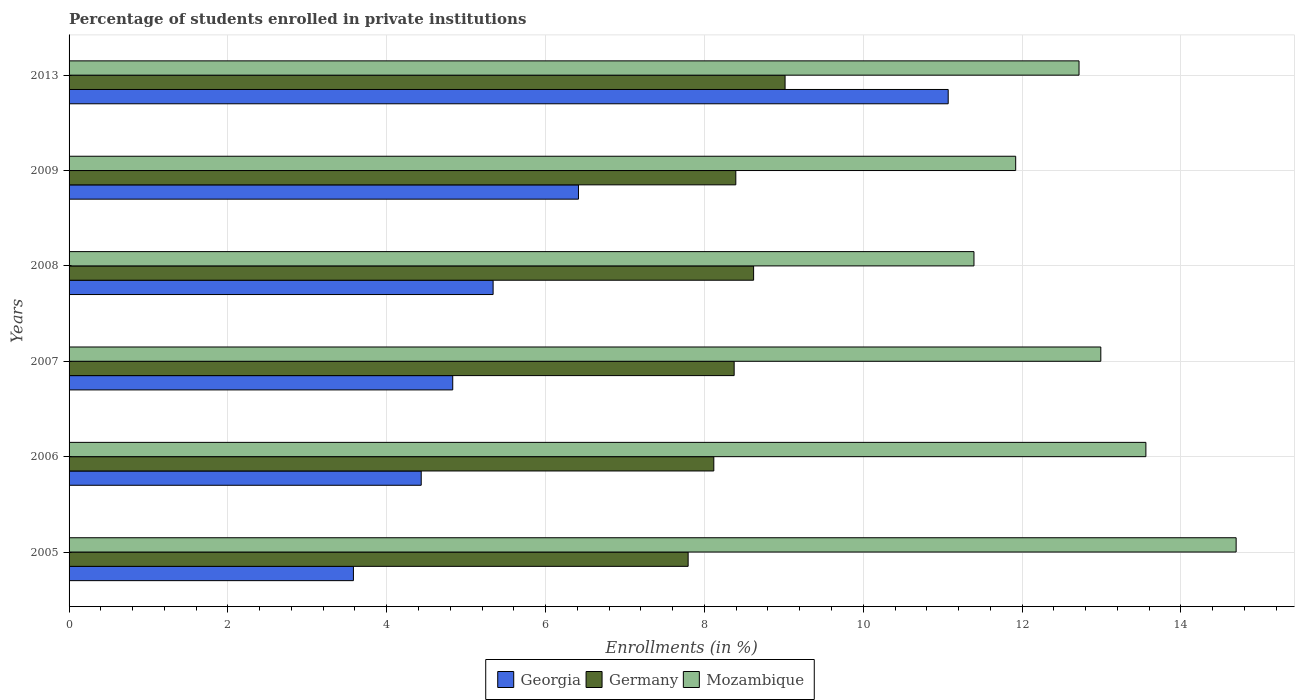How many different coloured bars are there?
Provide a succinct answer. 3. How many groups of bars are there?
Your response must be concise. 6. Are the number of bars per tick equal to the number of legend labels?
Give a very brief answer. Yes. What is the label of the 3rd group of bars from the top?
Provide a succinct answer. 2008. In how many cases, is the number of bars for a given year not equal to the number of legend labels?
Keep it short and to the point. 0. What is the percentage of trained teachers in Georgia in 2013?
Keep it short and to the point. 11.07. Across all years, what is the maximum percentage of trained teachers in Mozambique?
Provide a short and direct response. 14.7. Across all years, what is the minimum percentage of trained teachers in Germany?
Your response must be concise. 7.8. What is the total percentage of trained teachers in Germany in the graph?
Your answer should be compact. 50.32. What is the difference between the percentage of trained teachers in Germany in 2007 and that in 2008?
Offer a very short reply. -0.24. What is the difference between the percentage of trained teachers in Germany in 2008 and the percentage of trained teachers in Georgia in 2007?
Your response must be concise. 3.79. What is the average percentage of trained teachers in Georgia per year?
Your answer should be very brief. 5.94. In the year 2006, what is the difference between the percentage of trained teachers in Georgia and percentage of trained teachers in Mozambique?
Offer a terse response. -9.12. In how many years, is the percentage of trained teachers in Mozambique greater than 10.8 %?
Your answer should be very brief. 6. What is the ratio of the percentage of trained teachers in Germany in 2006 to that in 2009?
Provide a succinct answer. 0.97. Is the percentage of trained teachers in Georgia in 2006 less than that in 2013?
Your answer should be very brief. Yes. What is the difference between the highest and the second highest percentage of trained teachers in Georgia?
Keep it short and to the point. 4.66. What is the difference between the highest and the lowest percentage of trained teachers in Georgia?
Keep it short and to the point. 7.49. Is the sum of the percentage of trained teachers in Germany in 2005 and 2006 greater than the maximum percentage of trained teachers in Georgia across all years?
Your response must be concise. Yes. What does the 2nd bar from the top in 2006 represents?
Your response must be concise. Germany. What does the 1st bar from the bottom in 2007 represents?
Provide a succinct answer. Georgia. How many bars are there?
Your answer should be very brief. 18. What is the difference between two consecutive major ticks on the X-axis?
Your response must be concise. 2. What is the title of the graph?
Keep it short and to the point. Percentage of students enrolled in private institutions. Does "Syrian Arab Republic" appear as one of the legend labels in the graph?
Provide a succinct answer. No. What is the label or title of the X-axis?
Ensure brevity in your answer.  Enrollments (in %). What is the Enrollments (in %) in Georgia in 2005?
Give a very brief answer. 3.58. What is the Enrollments (in %) in Germany in 2005?
Offer a terse response. 7.8. What is the Enrollments (in %) of Mozambique in 2005?
Make the answer very short. 14.7. What is the Enrollments (in %) in Georgia in 2006?
Your response must be concise. 4.43. What is the Enrollments (in %) of Germany in 2006?
Offer a very short reply. 8.12. What is the Enrollments (in %) of Mozambique in 2006?
Offer a terse response. 13.56. What is the Enrollments (in %) of Georgia in 2007?
Ensure brevity in your answer.  4.83. What is the Enrollments (in %) of Germany in 2007?
Ensure brevity in your answer.  8.37. What is the Enrollments (in %) in Mozambique in 2007?
Make the answer very short. 12.99. What is the Enrollments (in %) in Georgia in 2008?
Offer a terse response. 5.34. What is the Enrollments (in %) in Germany in 2008?
Give a very brief answer. 8.62. What is the Enrollments (in %) of Mozambique in 2008?
Provide a short and direct response. 11.39. What is the Enrollments (in %) of Georgia in 2009?
Make the answer very short. 6.41. What is the Enrollments (in %) of Germany in 2009?
Offer a very short reply. 8.4. What is the Enrollments (in %) in Mozambique in 2009?
Ensure brevity in your answer.  11.92. What is the Enrollments (in %) in Georgia in 2013?
Your response must be concise. 11.07. What is the Enrollments (in %) of Germany in 2013?
Provide a short and direct response. 9.02. What is the Enrollments (in %) of Mozambique in 2013?
Offer a very short reply. 12.72. Across all years, what is the maximum Enrollments (in %) of Georgia?
Your response must be concise. 11.07. Across all years, what is the maximum Enrollments (in %) of Germany?
Your answer should be compact. 9.02. Across all years, what is the maximum Enrollments (in %) in Mozambique?
Your answer should be very brief. 14.7. Across all years, what is the minimum Enrollments (in %) in Georgia?
Your answer should be compact. 3.58. Across all years, what is the minimum Enrollments (in %) of Germany?
Ensure brevity in your answer.  7.8. Across all years, what is the minimum Enrollments (in %) in Mozambique?
Your answer should be very brief. 11.39. What is the total Enrollments (in %) in Georgia in the graph?
Keep it short and to the point. 35.67. What is the total Enrollments (in %) in Germany in the graph?
Ensure brevity in your answer.  50.32. What is the total Enrollments (in %) of Mozambique in the graph?
Ensure brevity in your answer.  77.28. What is the difference between the Enrollments (in %) in Georgia in 2005 and that in 2006?
Provide a short and direct response. -0.85. What is the difference between the Enrollments (in %) in Germany in 2005 and that in 2006?
Your response must be concise. -0.32. What is the difference between the Enrollments (in %) of Mozambique in 2005 and that in 2006?
Provide a succinct answer. 1.14. What is the difference between the Enrollments (in %) of Georgia in 2005 and that in 2007?
Give a very brief answer. -1.25. What is the difference between the Enrollments (in %) in Germany in 2005 and that in 2007?
Ensure brevity in your answer.  -0.58. What is the difference between the Enrollments (in %) in Mozambique in 2005 and that in 2007?
Make the answer very short. 1.7. What is the difference between the Enrollments (in %) of Georgia in 2005 and that in 2008?
Keep it short and to the point. -1.76. What is the difference between the Enrollments (in %) in Germany in 2005 and that in 2008?
Your answer should be compact. -0.82. What is the difference between the Enrollments (in %) in Mozambique in 2005 and that in 2008?
Provide a succinct answer. 3.3. What is the difference between the Enrollments (in %) of Georgia in 2005 and that in 2009?
Give a very brief answer. -2.83. What is the difference between the Enrollments (in %) in Germany in 2005 and that in 2009?
Offer a terse response. -0.6. What is the difference between the Enrollments (in %) of Mozambique in 2005 and that in 2009?
Ensure brevity in your answer.  2.78. What is the difference between the Enrollments (in %) in Georgia in 2005 and that in 2013?
Ensure brevity in your answer.  -7.49. What is the difference between the Enrollments (in %) in Germany in 2005 and that in 2013?
Your answer should be compact. -1.22. What is the difference between the Enrollments (in %) in Mozambique in 2005 and that in 2013?
Keep it short and to the point. 1.98. What is the difference between the Enrollments (in %) in Georgia in 2006 and that in 2007?
Ensure brevity in your answer.  -0.4. What is the difference between the Enrollments (in %) in Germany in 2006 and that in 2007?
Give a very brief answer. -0.26. What is the difference between the Enrollments (in %) of Mozambique in 2006 and that in 2007?
Offer a terse response. 0.57. What is the difference between the Enrollments (in %) of Georgia in 2006 and that in 2008?
Your answer should be compact. -0.91. What is the difference between the Enrollments (in %) in Germany in 2006 and that in 2008?
Keep it short and to the point. -0.5. What is the difference between the Enrollments (in %) of Mozambique in 2006 and that in 2008?
Your response must be concise. 2.16. What is the difference between the Enrollments (in %) in Georgia in 2006 and that in 2009?
Your response must be concise. -1.98. What is the difference between the Enrollments (in %) of Germany in 2006 and that in 2009?
Your answer should be compact. -0.28. What is the difference between the Enrollments (in %) of Mozambique in 2006 and that in 2009?
Offer a terse response. 1.64. What is the difference between the Enrollments (in %) of Georgia in 2006 and that in 2013?
Give a very brief answer. -6.64. What is the difference between the Enrollments (in %) of Germany in 2006 and that in 2013?
Your response must be concise. -0.9. What is the difference between the Enrollments (in %) in Mozambique in 2006 and that in 2013?
Provide a short and direct response. 0.84. What is the difference between the Enrollments (in %) of Georgia in 2007 and that in 2008?
Offer a very short reply. -0.51. What is the difference between the Enrollments (in %) in Germany in 2007 and that in 2008?
Make the answer very short. -0.24. What is the difference between the Enrollments (in %) of Mozambique in 2007 and that in 2008?
Offer a very short reply. 1.6. What is the difference between the Enrollments (in %) of Georgia in 2007 and that in 2009?
Make the answer very short. -1.58. What is the difference between the Enrollments (in %) in Germany in 2007 and that in 2009?
Give a very brief answer. -0.02. What is the difference between the Enrollments (in %) of Mozambique in 2007 and that in 2009?
Ensure brevity in your answer.  1.07. What is the difference between the Enrollments (in %) of Georgia in 2007 and that in 2013?
Provide a short and direct response. -6.24. What is the difference between the Enrollments (in %) of Germany in 2007 and that in 2013?
Offer a very short reply. -0.64. What is the difference between the Enrollments (in %) of Mozambique in 2007 and that in 2013?
Ensure brevity in your answer.  0.27. What is the difference between the Enrollments (in %) of Georgia in 2008 and that in 2009?
Offer a terse response. -1.07. What is the difference between the Enrollments (in %) in Germany in 2008 and that in 2009?
Offer a terse response. 0.22. What is the difference between the Enrollments (in %) of Mozambique in 2008 and that in 2009?
Offer a terse response. -0.53. What is the difference between the Enrollments (in %) of Georgia in 2008 and that in 2013?
Your answer should be very brief. -5.73. What is the difference between the Enrollments (in %) in Germany in 2008 and that in 2013?
Keep it short and to the point. -0.4. What is the difference between the Enrollments (in %) of Mozambique in 2008 and that in 2013?
Your response must be concise. -1.32. What is the difference between the Enrollments (in %) in Georgia in 2009 and that in 2013?
Keep it short and to the point. -4.66. What is the difference between the Enrollments (in %) in Germany in 2009 and that in 2013?
Your answer should be compact. -0.62. What is the difference between the Enrollments (in %) of Mozambique in 2009 and that in 2013?
Offer a very short reply. -0.8. What is the difference between the Enrollments (in %) in Georgia in 2005 and the Enrollments (in %) in Germany in 2006?
Make the answer very short. -4.54. What is the difference between the Enrollments (in %) of Georgia in 2005 and the Enrollments (in %) of Mozambique in 2006?
Offer a terse response. -9.98. What is the difference between the Enrollments (in %) in Germany in 2005 and the Enrollments (in %) in Mozambique in 2006?
Your response must be concise. -5.76. What is the difference between the Enrollments (in %) of Georgia in 2005 and the Enrollments (in %) of Germany in 2007?
Provide a short and direct response. -4.79. What is the difference between the Enrollments (in %) in Georgia in 2005 and the Enrollments (in %) in Mozambique in 2007?
Ensure brevity in your answer.  -9.41. What is the difference between the Enrollments (in %) in Germany in 2005 and the Enrollments (in %) in Mozambique in 2007?
Provide a short and direct response. -5.2. What is the difference between the Enrollments (in %) in Georgia in 2005 and the Enrollments (in %) in Germany in 2008?
Provide a short and direct response. -5.04. What is the difference between the Enrollments (in %) in Georgia in 2005 and the Enrollments (in %) in Mozambique in 2008?
Offer a very short reply. -7.81. What is the difference between the Enrollments (in %) of Germany in 2005 and the Enrollments (in %) of Mozambique in 2008?
Ensure brevity in your answer.  -3.6. What is the difference between the Enrollments (in %) of Georgia in 2005 and the Enrollments (in %) of Germany in 2009?
Provide a succinct answer. -4.81. What is the difference between the Enrollments (in %) in Georgia in 2005 and the Enrollments (in %) in Mozambique in 2009?
Make the answer very short. -8.34. What is the difference between the Enrollments (in %) in Germany in 2005 and the Enrollments (in %) in Mozambique in 2009?
Keep it short and to the point. -4.12. What is the difference between the Enrollments (in %) of Georgia in 2005 and the Enrollments (in %) of Germany in 2013?
Make the answer very short. -5.44. What is the difference between the Enrollments (in %) in Georgia in 2005 and the Enrollments (in %) in Mozambique in 2013?
Your answer should be compact. -9.14. What is the difference between the Enrollments (in %) in Germany in 2005 and the Enrollments (in %) in Mozambique in 2013?
Provide a short and direct response. -4.92. What is the difference between the Enrollments (in %) of Georgia in 2006 and the Enrollments (in %) of Germany in 2007?
Offer a very short reply. -3.94. What is the difference between the Enrollments (in %) in Georgia in 2006 and the Enrollments (in %) in Mozambique in 2007?
Your response must be concise. -8.56. What is the difference between the Enrollments (in %) in Germany in 2006 and the Enrollments (in %) in Mozambique in 2007?
Keep it short and to the point. -4.87. What is the difference between the Enrollments (in %) of Georgia in 2006 and the Enrollments (in %) of Germany in 2008?
Ensure brevity in your answer.  -4.19. What is the difference between the Enrollments (in %) in Georgia in 2006 and the Enrollments (in %) in Mozambique in 2008?
Give a very brief answer. -6.96. What is the difference between the Enrollments (in %) of Germany in 2006 and the Enrollments (in %) of Mozambique in 2008?
Keep it short and to the point. -3.28. What is the difference between the Enrollments (in %) in Georgia in 2006 and the Enrollments (in %) in Germany in 2009?
Your answer should be very brief. -3.96. What is the difference between the Enrollments (in %) in Georgia in 2006 and the Enrollments (in %) in Mozambique in 2009?
Your response must be concise. -7.49. What is the difference between the Enrollments (in %) of Germany in 2006 and the Enrollments (in %) of Mozambique in 2009?
Give a very brief answer. -3.8. What is the difference between the Enrollments (in %) of Georgia in 2006 and the Enrollments (in %) of Germany in 2013?
Provide a short and direct response. -4.58. What is the difference between the Enrollments (in %) of Georgia in 2006 and the Enrollments (in %) of Mozambique in 2013?
Give a very brief answer. -8.28. What is the difference between the Enrollments (in %) in Germany in 2006 and the Enrollments (in %) in Mozambique in 2013?
Your answer should be very brief. -4.6. What is the difference between the Enrollments (in %) in Georgia in 2007 and the Enrollments (in %) in Germany in 2008?
Your response must be concise. -3.79. What is the difference between the Enrollments (in %) in Georgia in 2007 and the Enrollments (in %) in Mozambique in 2008?
Your answer should be very brief. -6.56. What is the difference between the Enrollments (in %) of Germany in 2007 and the Enrollments (in %) of Mozambique in 2008?
Offer a very short reply. -3.02. What is the difference between the Enrollments (in %) in Georgia in 2007 and the Enrollments (in %) in Germany in 2009?
Provide a succinct answer. -3.56. What is the difference between the Enrollments (in %) in Georgia in 2007 and the Enrollments (in %) in Mozambique in 2009?
Keep it short and to the point. -7.09. What is the difference between the Enrollments (in %) in Germany in 2007 and the Enrollments (in %) in Mozambique in 2009?
Ensure brevity in your answer.  -3.54. What is the difference between the Enrollments (in %) in Georgia in 2007 and the Enrollments (in %) in Germany in 2013?
Provide a succinct answer. -4.18. What is the difference between the Enrollments (in %) of Georgia in 2007 and the Enrollments (in %) of Mozambique in 2013?
Make the answer very short. -7.89. What is the difference between the Enrollments (in %) in Germany in 2007 and the Enrollments (in %) in Mozambique in 2013?
Your answer should be very brief. -4.34. What is the difference between the Enrollments (in %) of Georgia in 2008 and the Enrollments (in %) of Germany in 2009?
Make the answer very short. -3.06. What is the difference between the Enrollments (in %) in Georgia in 2008 and the Enrollments (in %) in Mozambique in 2009?
Make the answer very short. -6.58. What is the difference between the Enrollments (in %) of Georgia in 2008 and the Enrollments (in %) of Germany in 2013?
Offer a terse response. -3.68. What is the difference between the Enrollments (in %) of Georgia in 2008 and the Enrollments (in %) of Mozambique in 2013?
Give a very brief answer. -7.38. What is the difference between the Enrollments (in %) in Germany in 2008 and the Enrollments (in %) in Mozambique in 2013?
Your answer should be compact. -4.1. What is the difference between the Enrollments (in %) of Georgia in 2009 and the Enrollments (in %) of Germany in 2013?
Make the answer very short. -2.6. What is the difference between the Enrollments (in %) in Georgia in 2009 and the Enrollments (in %) in Mozambique in 2013?
Give a very brief answer. -6.3. What is the difference between the Enrollments (in %) in Germany in 2009 and the Enrollments (in %) in Mozambique in 2013?
Provide a short and direct response. -4.32. What is the average Enrollments (in %) of Georgia per year?
Your answer should be compact. 5.94. What is the average Enrollments (in %) of Germany per year?
Your answer should be very brief. 8.39. What is the average Enrollments (in %) in Mozambique per year?
Provide a succinct answer. 12.88. In the year 2005, what is the difference between the Enrollments (in %) of Georgia and Enrollments (in %) of Germany?
Keep it short and to the point. -4.21. In the year 2005, what is the difference between the Enrollments (in %) in Georgia and Enrollments (in %) in Mozambique?
Provide a succinct answer. -11.11. In the year 2005, what is the difference between the Enrollments (in %) in Germany and Enrollments (in %) in Mozambique?
Offer a very short reply. -6.9. In the year 2006, what is the difference between the Enrollments (in %) of Georgia and Enrollments (in %) of Germany?
Provide a short and direct response. -3.68. In the year 2006, what is the difference between the Enrollments (in %) of Georgia and Enrollments (in %) of Mozambique?
Make the answer very short. -9.12. In the year 2006, what is the difference between the Enrollments (in %) of Germany and Enrollments (in %) of Mozambique?
Offer a very short reply. -5.44. In the year 2007, what is the difference between the Enrollments (in %) in Georgia and Enrollments (in %) in Germany?
Offer a very short reply. -3.54. In the year 2007, what is the difference between the Enrollments (in %) in Georgia and Enrollments (in %) in Mozambique?
Ensure brevity in your answer.  -8.16. In the year 2007, what is the difference between the Enrollments (in %) in Germany and Enrollments (in %) in Mozambique?
Provide a succinct answer. -4.62. In the year 2008, what is the difference between the Enrollments (in %) of Georgia and Enrollments (in %) of Germany?
Make the answer very short. -3.28. In the year 2008, what is the difference between the Enrollments (in %) in Georgia and Enrollments (in %) in Mozambique?
Keep it short and to the point. -6.05. In the year 2008, what is the difference between the Enrollments (in %) of Germany and Enrollments (in %) of Mozambique?
Make the answer very short. -2.77. In the year 2009, what is the difference between the Enrollments (in %) in Georgia and Enrollments (in %) in Germany?
Offer a very short reply. -1.98. In the year 2009, what is the difference between the Enrollments (in %) of Georgia and Enrollments (in %) of Mozambique?
Your answer should be very brief. -5.51. In the year 2009, what is the difference between the Enrollments (in %) of Germany and Enrollments (in %) of Mozambique?
Offer a very short reply. -3.52. In the year 2013, what is the difference between the Enrollments (in %) of Georgia and Enrollments (in %) of Germany?
Ensure brevity in your answer.  2.05. In the year 2013, what is the difference between the Enrollments (in %) in Georgia and Enrollments (in %) in Mozambique?
Provide a short and direct response. -1.65. In the year 2013, what is the difference between the Enrollments (in %) in Germany and Enrollments (in %) in Mozambique?
Provide a short and direct response. -3.7. What is the ratio of the Enrollments (in %) in Georgia in 2005 to that in 2006?
Keep it short and to the point. 0.81. What is the ratio of the Enrollments (in %) of Germany in 2005 to that in 2006?
Keep it short and to the point. 0.96. What is the ratio of the Enrollments (in %) in Mozambique in 2005 to that in 2006?
Offer a terse response. 1.08. What is the ratio of the Enrollments (in %) in Georgia in 2005 to that in 2007?
Offer a very short reply. 0.74. What is the ratio of the Enrollments (in %) in Germany in 2005 to that in 2007?
Ensure brevity in your answer.  0.93. What is the ratio of the Enrollments (in %) in Mozambique in 2005 to that in 2007?
Your response must be concise. 1.13. What is the ratio of the Enrollments (in %) of Georgia in 2005 to that in 2008?
Provide a short and direct response. 0.67. What is the ratio of the Enrollments (in %) in Germany in 2005 to that in 2008?
Make the answer very short. 0.9. What is the ratio of the Enrollments (in %) in Mozambique in 2005 to that in 2008?
Provide a short and direct response. 1.29. What is the ratio of the Enrollments (in %) of Georgia in 2005 to that in 2009?
Offer a very short reply. 0.56. What is the ratio of the Enrollments (in %) in Germany in 2005 to that in 2009?
Ensure brevity in your answer.  0.93. What is the ratio of the Enrollments (in %) in Mozambique in 2005 to that in 2009?
Provide a short and direct response. 1.23. What is the ratio of the Enrollments (in %) of Georgia in 2005 to that in 2013?
Provide a succinct answer. 0.32. What is the ratio of the Enrollments (in %) of Germany in 2005 to that in 2013?
Offer a very short reply. 0.86. What is the ratio of the Enrollments (in %) in Mozambique in 2005 to that in 2013?
Offer a very short reply. 1.16. What is the ratio of the Enrollments (in %) of Georgia in 2006 to that in 2007?
Offer a terse response. 0.92. What is the ratio of the Enrollments (in %) of Germany in 2006 to that in 2007?
Your answer should be compact. 0.97. What is the ratio of the Enrollments (in %) of Mozambique in 2006 to that in 2007?
Make the answer very short. 1.04. What is the ratio of the Enrollments (in %) in Georgia in 2006 to that in 2008?
Provide a succinct answer. 0.83. What is the ratio of the Enrollments (in %) in Germany in 2006 to that in 2008?
Ensure brevity in your answer.  0.94. What is the ratio of the Enrollments (in %) in Mozambique in 2006 to that in 2008?
Give a very brief answer. 1.19. What is the ratio of the Enrollments (in %) of Georgia in 2006 to that in 2009?
Ensure brevity in your answer.  0.69. What is the ratio of the Enrollments (in %) in Germany in 2006 to that in 2009?
Give a very brief answer. 0.97. What is the ratio of the Enrollments (in %) of Mozambique in 2006 to that in 2009?
Offer a very short reply. 1.14. What is the ratio of the Enrollments (in %) in Georgia in 2006 to that in 2013?
Your answer should be compact. 0.4. What is the ratio of the Enrollments (in %) of Germany in 2006 to that in 2013?
Provide a succinct answer. 0.9. What is the ratio of the Enrollments (in %) of Mozambique in 2006 to that in 2013?
Provide a succinct answer. 1.07. What is the ratio of the Enrollments (in %) of Georgia in 2007 to that in 2008?
Give a very brief answer. 0.9. What is the ratio of the Enrollments (in %) of Germany in 2007 to that in 2008?
Ensure brevity in your answer.  0.97. What is the ratio of the Enrollments (in %) in Mozambique in 2007 to that in 2008?
Your answer should be very brief. 1.14. What is the ratio of the Enrollments (in %) of Georgia in 2007 to that in 2009?
Your answer should be compact. 0.75. What is the ratio of the Enrollments (in %) of Mozambique in 2007 to that in 2009?
Give a very brief answer. 1.09. What is the ratio of the Enrollments (in %) of Georgia in 2007 to that in 2013?
Ensure brevity in your answer.  0.44. What is the ratio of the Enrollments (in %) in Germany in 2007 to that in 2013?
Your answer should be compact. 0.93. What is the ratio of the Enrollments (in %) in Mozambique in 2007 to that in 2013?
Give a very brief answer. 1.02. What is the ratio of the Enrollments (in %) of Georgia in 2008 to that in 2009?
Offer a terse response. 0.83. What is the ratio of the Enrollments (in %) of Germany in 2008 to that in 2009?
Your answer should be compact. 1.03. What is the ratio of the Enrollments (in %) in Mozambique in 2008 to that in 2009?
Your answer should be very brief. 0.96. What is the ratio of the Enrollments (in %) of Georgia in 2008 to that in 2013?
Provide a succinct answer. 0.48. What is the ratio of the Enrollments (in %) of Germany in 2008 to that in 2013?
Ensure brevity in your answer.  0.96. What is the ratio of the Enrollments (in %) in Mozambique in 2008 to that in 2013?
Keep it short and to the point. 0.9. What is the ratio of the Enrollments (in %) of Georgia in 2009 to that in 2013?
Provide a succinct answer. 0.58. What is the ratio of the Enrollments (in %) of Germany in 2009 to that in 2013?
Give a very brief answer. 0.93. What is the ratio of the Enrollments (in %) of Mozambique in 2009 to that in 2013?
Offer a very short reply. 0.94. What is the difference between the highest and the second highest Enrollments (in %) in Georgia?
Offer a very short reply. 4.66. What is the difference between the highest and the second highest Enrollments (in %) of Germany?
Make the answer very short. 0.4. What is the difference between the highest and the second highest Enrollments (in %) in Mozambique?
Ensure brevity in your answer.  1.14. What is the difference between the highest and the lowest Enrollments (in %) in Georgia?
Your answer should be very brief. 7.49. What is the difference between the highest and the lowest Enrollments (in %) in Germany?
Your answer should be very brief. 1.22. What is the difference between the highest and the lowest Enrollments (in %) in Mozambique?
Your answer should be very brief. 3.3. 